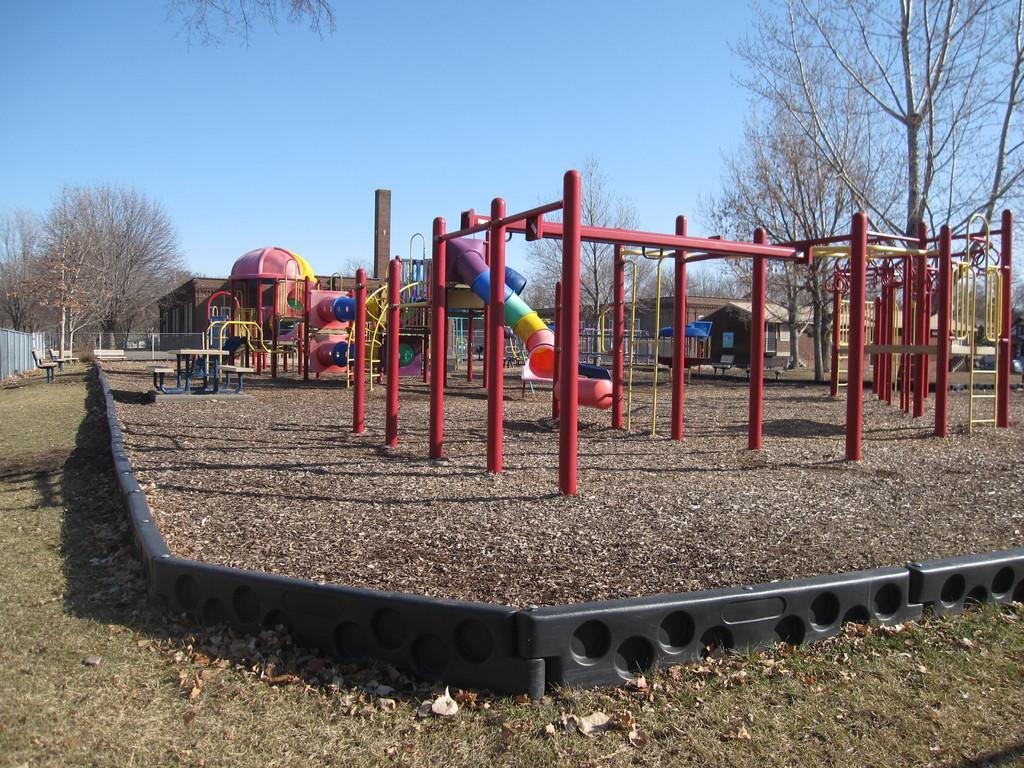Can you describe this image briefly? In this image I can see the red color metal rods. To the side of these metal rods I can see the toys which are colorful. In the background I can see the houses, trees and the blue sky. And I can see the black color compound wall. 